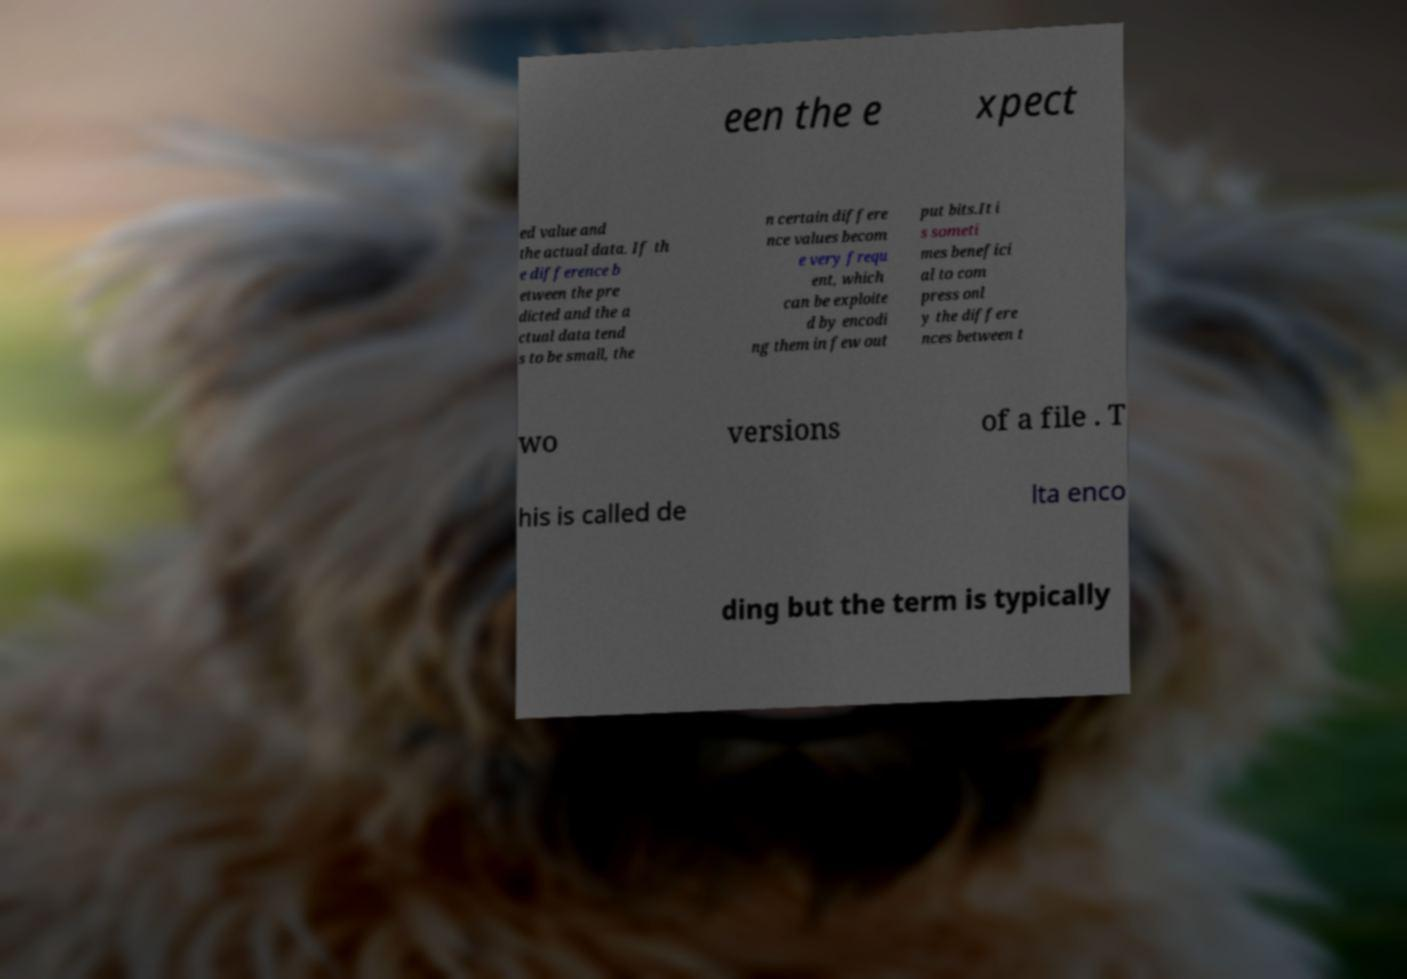What messages or text are displayed in this image? I need them in a readable, typed format. een the e xpect ed value and the actual data. If th e difference b etween the pre dicted and the a ctual data tend s to be small, the n certain differe nce values becom e very frequ ent, which can be exploite d by encodi ng them in few out put bits.It i s someti mes benefici al to com press onl y the differe nces between t wo versions of a file . T his is called de lta enco ding but the term is typically 